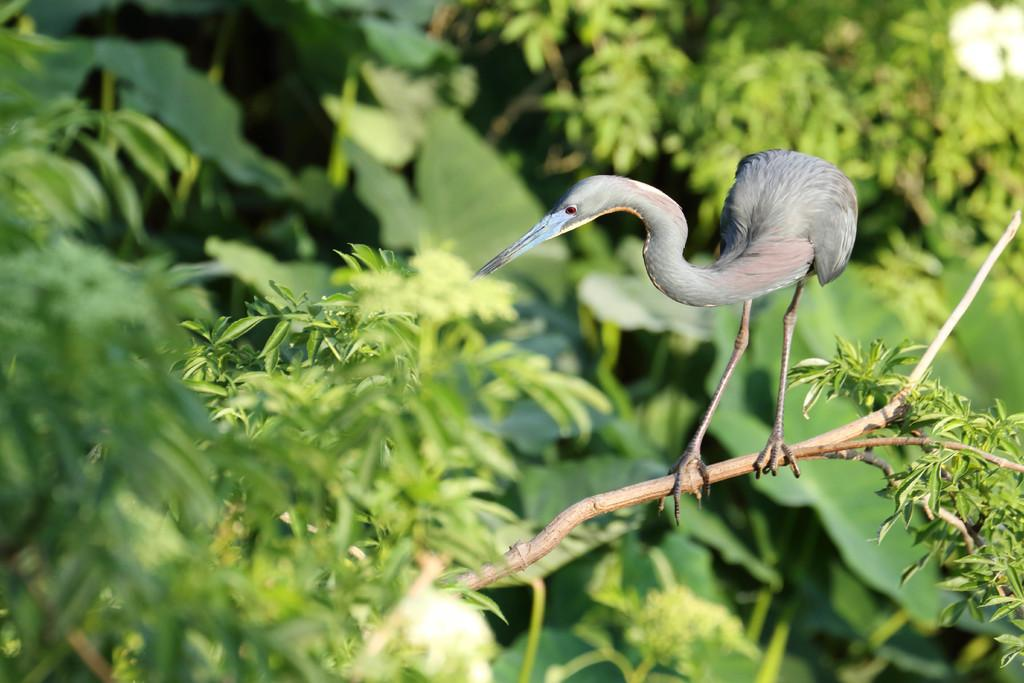What type of animal can be seen in the image? There is a bird in the image. Where is the bird located? The bird is on a tree. What can be seen behind the bird? There is a group of trees visible behind the bird. What is the process of the bird's migration in the image? The image does not show the bird in the process of migration, nor does it provide any information about the bird's migration. 